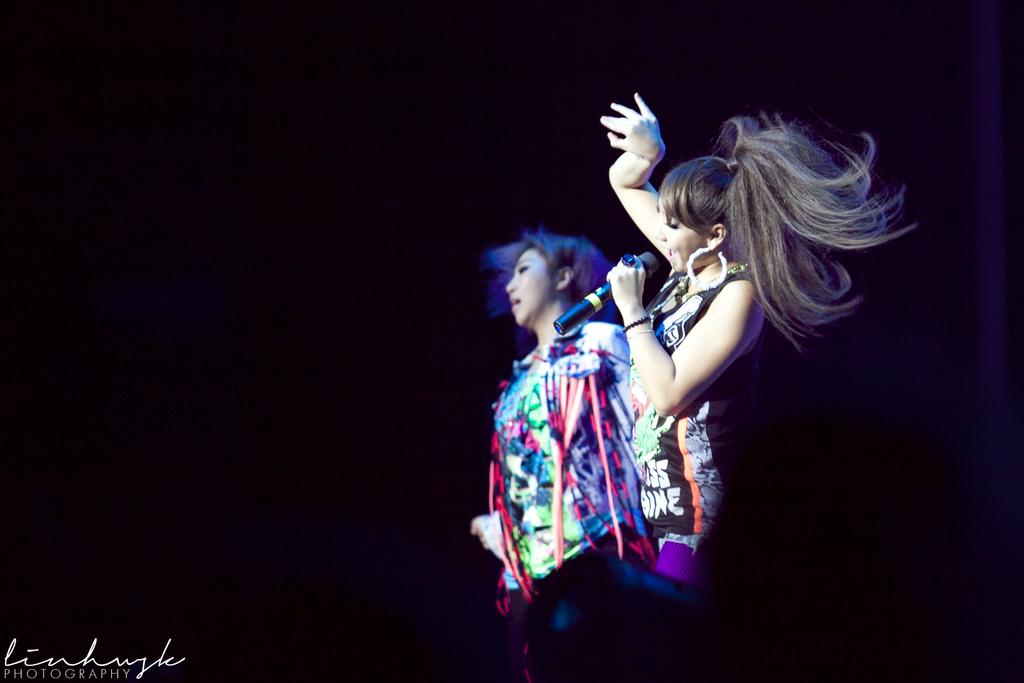How many women are in the image? There are two women in the image. What are the women wearing? Both women are wearing colorful dresses. What are the women doing in the image? The women are standing, and the woman in front is holding a microphone. What can be observed about the background of the image? The background of the image is dark. Are there any slaves depicted in the image? No, there are no slaves depicted in the image. What type of hate can be seen on the faces of the women in the image? There is no indication of hate on the faces of the women in the image. 